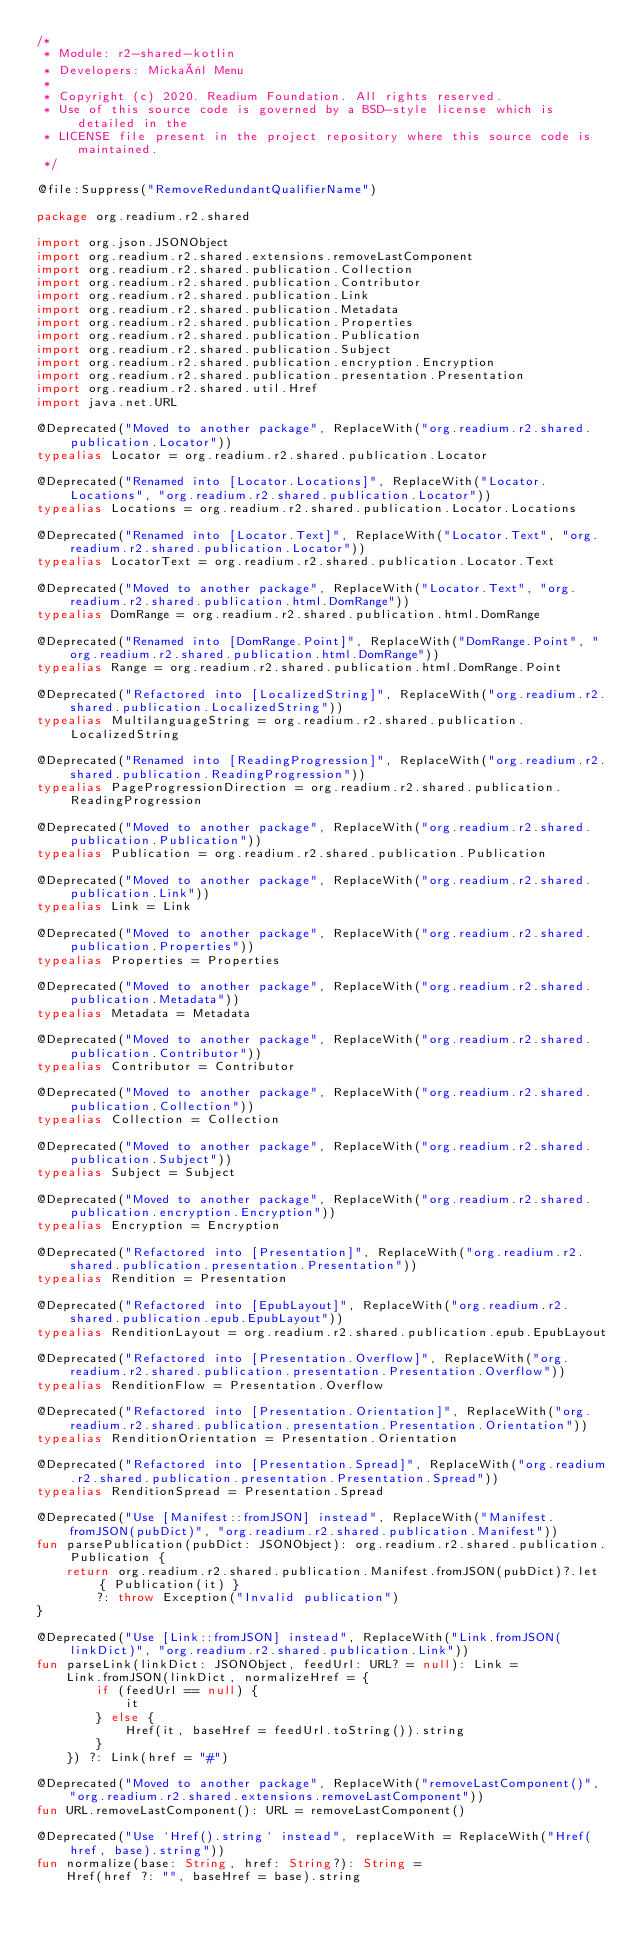Convert code to text. <code><loc_0><loc_0><loc_500><loc_500><_Kotlin_>/*
 * Module: r2-shared-kotlin
 * Developers: Mickaël Menu
 *
 * Copyright (c) 2020. Readium Foundation. All rights reserved.
 * Use of this source code is governed by a BSD-style license which is detailed in the
 * LICENSE file present in the project repository where this source code is maintained.
 */

@file:Suppress("RemoveRedundantQualifierName")

package org.readium.r2.shared

import org.json.JSONObject
import org.readium.r2.shared.extensions.removeLastComponent
import org.readium.r2.shared.publication.Collection
import org.readium.r2.shared.publication.Contributor
import org.readium.r2.shared.publication.Link
import org.readium.r2.shared.publication.Metadata
import org.readium.r2.shared.publication.Properties
import org.readium.r2.shared.publication.Publication
import org.readium.r2.shared.publication.Subject
import org.readium.r2.shared.publication.encryption.Encryption
import org.readium.r2.shared.publication.presentation.Presentation
import org.readium.r2.shared.util.Href
import java.net.URL

@Deprecated("Moved to another package", ReplaceWith("org.readium.r2.shared.publication.Locator"))
typealias Locator = org.readium.r2.shared.publication.Locator

@Deprecated("Renamed into [Locator.Locations]", ReplaceWith("Locator.Locations", "org.readium.r2.shared.publication.Locator"))
typealias Locations = org.readium.r2.shared.publication.Locator.Locations

@Deprecated("Renamed into [Locator.Text]", ReplaceWith("Locator.Text", "org.readium.r2.shared.publication.Locator"))
typealias LocatorText = org.readium.r2.shared.publication.Locator.Text

@Deprecated("Moved to another package", ReplaceWith("Locator.Text", "org.readium.r2.shared.publication.html.DomRange"))
typealias DomRange = org.readium.r2.shared.publication.html.DomRange

@Deprecated("Renamed into [DomRange.Point]", ReplaceWith("DomRange.Point", "org.readium.r2.shared.publication.html.DomRange"))
typealias Range = org.readium.r2.shared.publication.html.DomRange.Point

@Deprecated("Refactored into [LocalizedString]", ReplaceWith("org.readium.r2.shared.publication.LocalizedString"))
typealias MultilanguageString = org.readium.r2.shared.publication.LocalizedString

@Deprecated("Renamed into [ReadingProgression]", ReplaceWith("org.readium.r2.shared.publication.ReadingProgression"))
typealias PageProgressionDirection = org.readium.r2.shared.publication.ReadingProgression

@Deprecated("Moved to another package", ReplaceWith("org.readium.r2.shared.publication.Publication"))
typealias Publication = org.readium.r2.shared.publication.Publication

@Deprecated("Moved to another package", ReplaceWith("org.readium.r2.shared.publication.Link"))
typealias Link = Link

@Deprecated("Moved to another package", ReplaceWith("org.readium.r2.shared.publication.Properties"))
typealias Properties = Properties

@Deprecated("Moved to another package", ReplaceWith("org.readium.r2.shared.publication.Metadata"))
typealias Metadata = Metadata

@Deprecated("Moved to another package", ReplaceWith("org.readium.r2.shared.publication.Contributor"))
typealias Contributor = Contributor

@Deprecated("Moved to another package", ReplaceWith("org.readium.r2.shared.publication.Collection"))
typealias Collection = Collection

@Deprecated("Moved to another package", ReplaceWith("org.readium.r2.shared.publication.Subject"))
typealias Subject = Subject

@Deprecated("Moved to another package", ReplaceWith("org.readium.r2.shared.publication.encryption.Encryption"))
typealias Encryption = Encryption

@Deprecated("Refactored into [Presentation]", ReplaceWith("org.readium.r2.shared.publication.presentation.Presentation"))
typealias Rendition = Presentation

@Deprecated("Refactored into [EpubLayout]", ReplaceWith("org.readium.r2.shared.publication.epub.EpubLayout"))
typealias RenditionLayout = org.readium.r2.shared.publication.epub.EpubLayout

@Deprecated("Refactored into [Presentation.Overflow]", ReplaceWith("org.readium.r2.shared.publication.presentation.Presentation.Overflow"))
typealias RenditionFlow = Presentation.Overflow

@Deprecated("Refactored into [Presentation.Orientation]", ReplaceWith("org.readium.r2.shared.publication.presentation.Presentation.Orientation"))
typealias RenditionOrientation = Presentation.Orientation

@Deprecated("Refactored into [Presentation.Spread]", ReplaceWith("org.readium.r2.shared.publication.presentation.Presentation.Spread"))
typealias RenditionSpread = Presentation.Spread

@Deprecated("Use [Manifest::fromJSON] instead", ReplaceWith("Manifest.fromJSON(pubDict)", "org.readium.r2.shared.publication.Manifest"))
fun parsePublication(pubDict: JSONObject): org.readium.r2.shared.publication.Publication {
    return org.readium.r2.shared.publication.Manifest.fromJSON(pubDict)?.let { Publication(it) }
        ?: throw Exception("Invalid publication")
}

@Deprecated("Use [Link::fromJSON] instead", ReplaceWith("Link.fromJSON(linkDict)", "org.readium.r2.shared.publication.Link"))
fun parseLink(linkDict: JSONObject, feedUrl: URL? = null): Link =
    Link.fromJSON(linkDict, normalizeHref = {
        if (feedUrl == null) {
            it
        } else {
            Href(it, baseHref = feedUrl.toString()).string
        }
    }) ?: Link(href = "#")

@Deprecated("Moved to another package", ReplaceWith("removeLastComponent()", "org.readium.r2.shared.extensions.removeLastComponent"))
fun URL.removeLastComponent(): URL = removeLastComponent()

@Deprecated("Use `Href().string` instead", replaceWith = ReplaceWith("Href(href, base).string"))
fun normalize(base: String, href: String?): String =
    Href(href ?: "", baseHref = base).string
</code> 